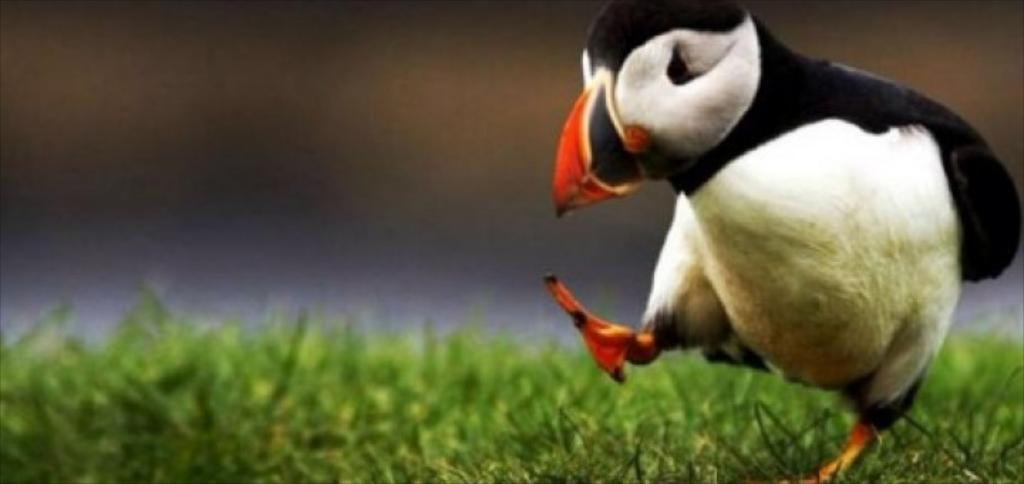What type of animal is in the image? There is a puffin in the image. What is the puffin doing in the image? The puffin is dancing on the ground. What verse is the rabbit reciting while the worm is dancing in the image? There is no rabbit or worm present in the image; it features a puffin dancing on the ground. 